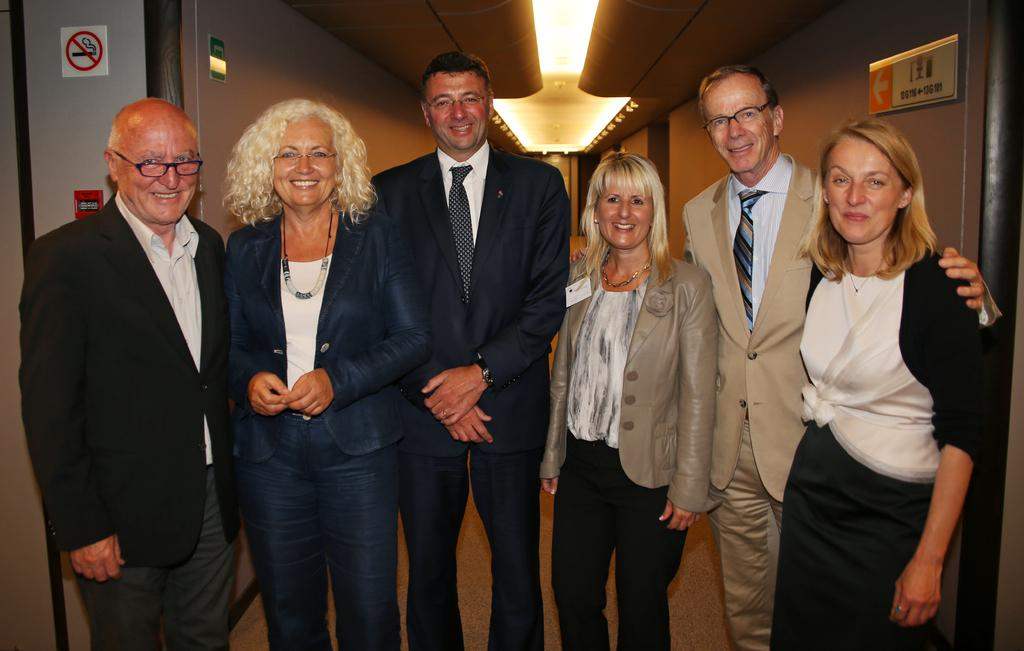How many people are in the image? There is a group of people in the image. What are the people wearing? The people are wearing different color dresses. What can be seen on the wall in the background of the image? There are boards on the wall in the background of the image. What is visible at the top of the image? There are lights visible in the top of the image. Are there any trees visible in the image? There are no trees visible in the image. What type of sticks are being used by the people in the image? There are no sticks present in the image. 